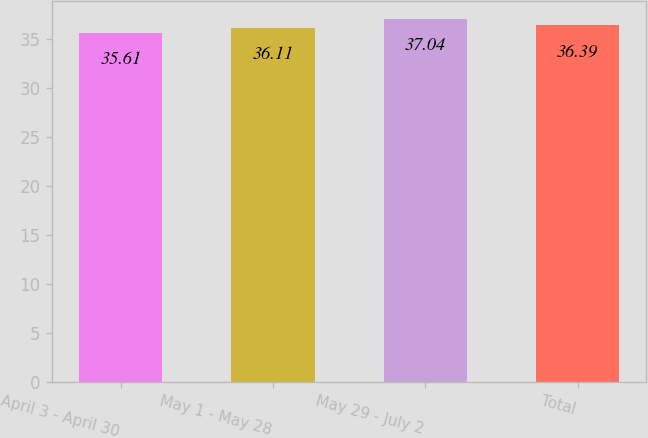<chart> <loc_0><loc_0><loc_500><loc_500><bar_chart><fcel>April 3 - April 30<fcel>May 1 - May 28<fcel>May 29 - July 2<fcel>Total<nl><fcel>35.61<fcel>36.11<fcel>37.04<fcel>36.39<nl></chart> 